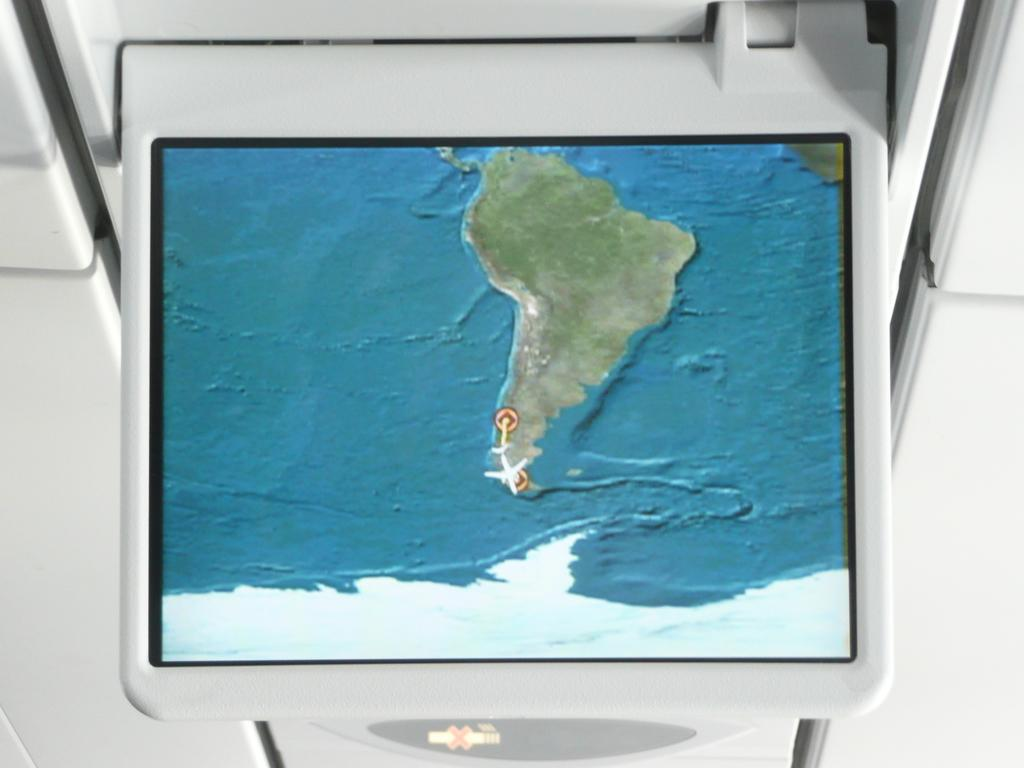What is the main object in the image? There is a monitor screen in the image. What is being shown on the monitor screen? A map is being displayed on the monitor screen. What time is displayed on the monitor screen? The image does not show any time displayed on the monitor screen; it only shows a map. 